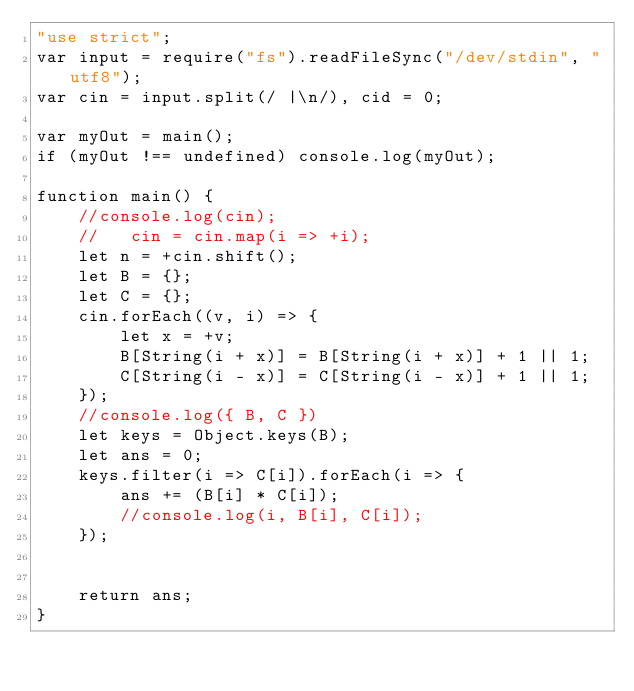<code> <loc_0><loc_0><loc_500><loc_500><_JavaScript_>"use strict";
var input = require("fs").readFileSync("/dev/stdin", "utf8");
var cin = input.split(/ |\n/), cid = 0;

var myOut = main();
if (myOut !== undefined) console.log(myOut);

function main() {
    //console.log(cin);
    //   cin = cin.map(i => +i);
    let n = +cin.shift();
    let B = {};
    let C = {};
    cin.forEach((v, i) => {
        let x = +v;
        B[String(i + x)] = B[String(i + x)] + 1 || 1;
        C[String(i - x)] = C[String(i - x)] + 1 || 1;
    });
    //console.log({ B, C })
    let keys = Object.keys(B);
    let ans = 0;
    keys.filter(i => C[i]).forEach(i => {
        ans += (B[i] * C[i]);
        //console.log(i, B[i], C[i]);
    });


    return ans;
}</code> 